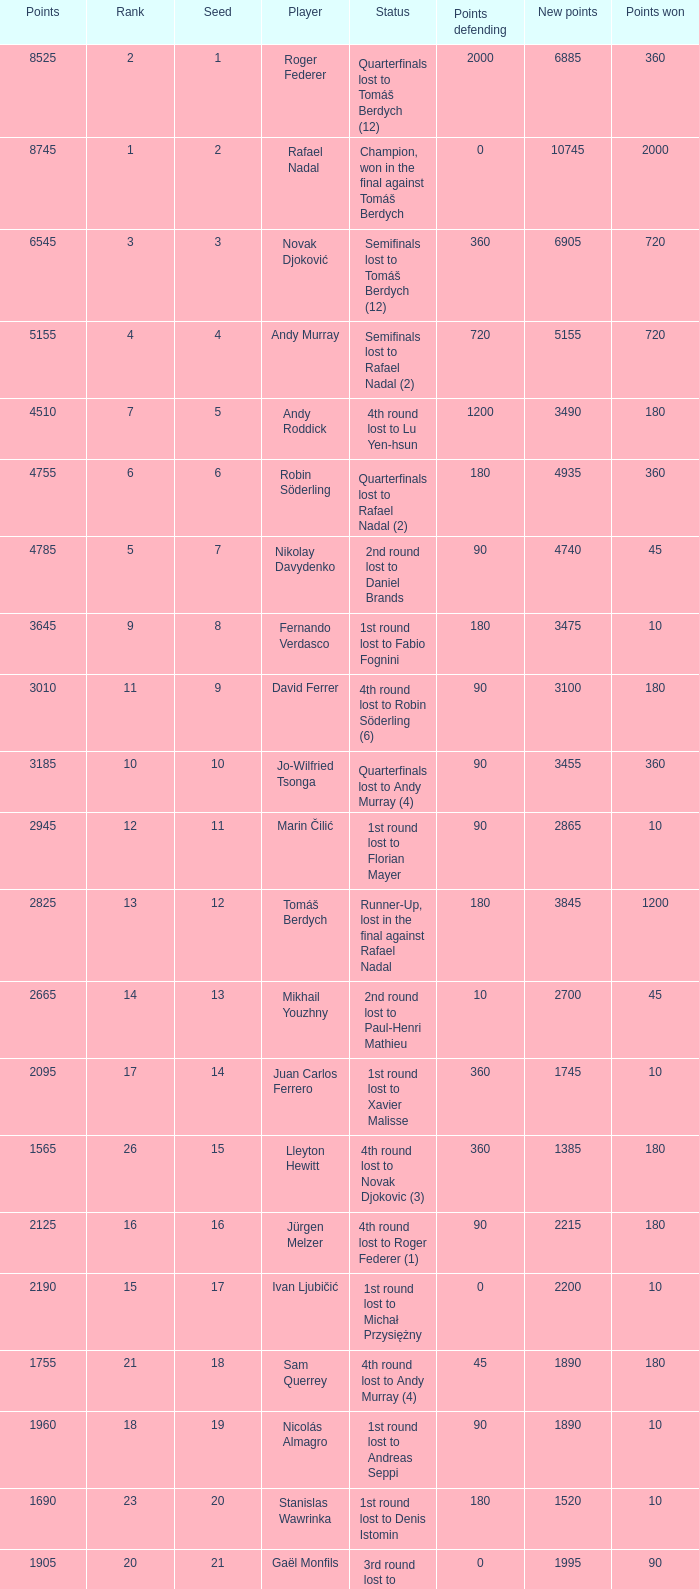Name the points won for 1230 90.0. 